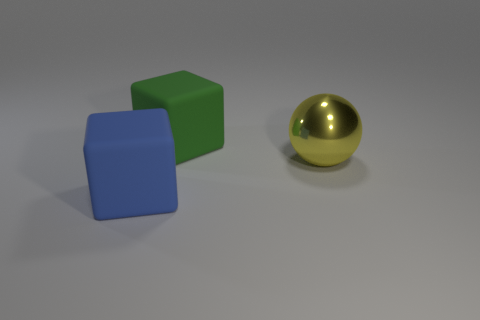Add 3 large blue things. How many objects exist? 6 Subtract all spheres. How many objects are left? 2 Subtract all blue shiny balls. Subtract all large green rubber objects. How many objects are left? 2 Add 1 large green rubber cubes. How many large green rubber cubes are left? 2 Add 2 cyan shiny spheres. How many cyan shiny spheres exist? 2 Subtract 0 purple blocks. How many objects are left? 3 